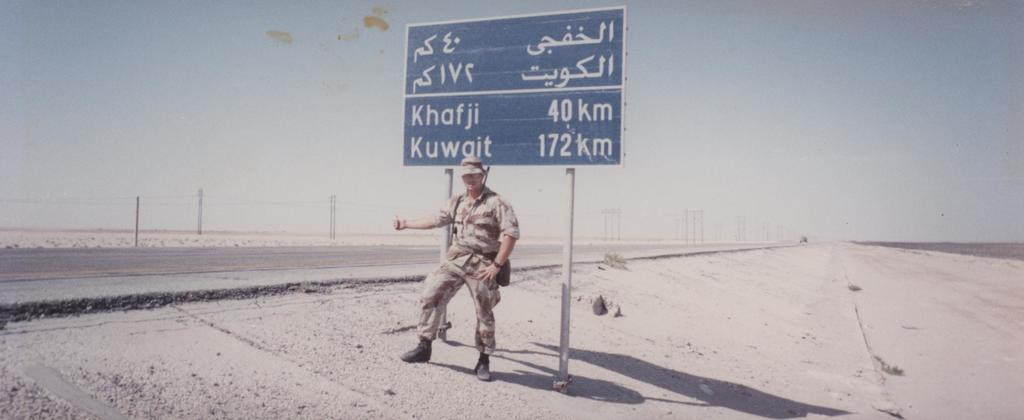Provide a one-sentence caption for the provided image. A soldier is in a hitchhiking position by a sign that shows Khafji at 40 kilometers away. 